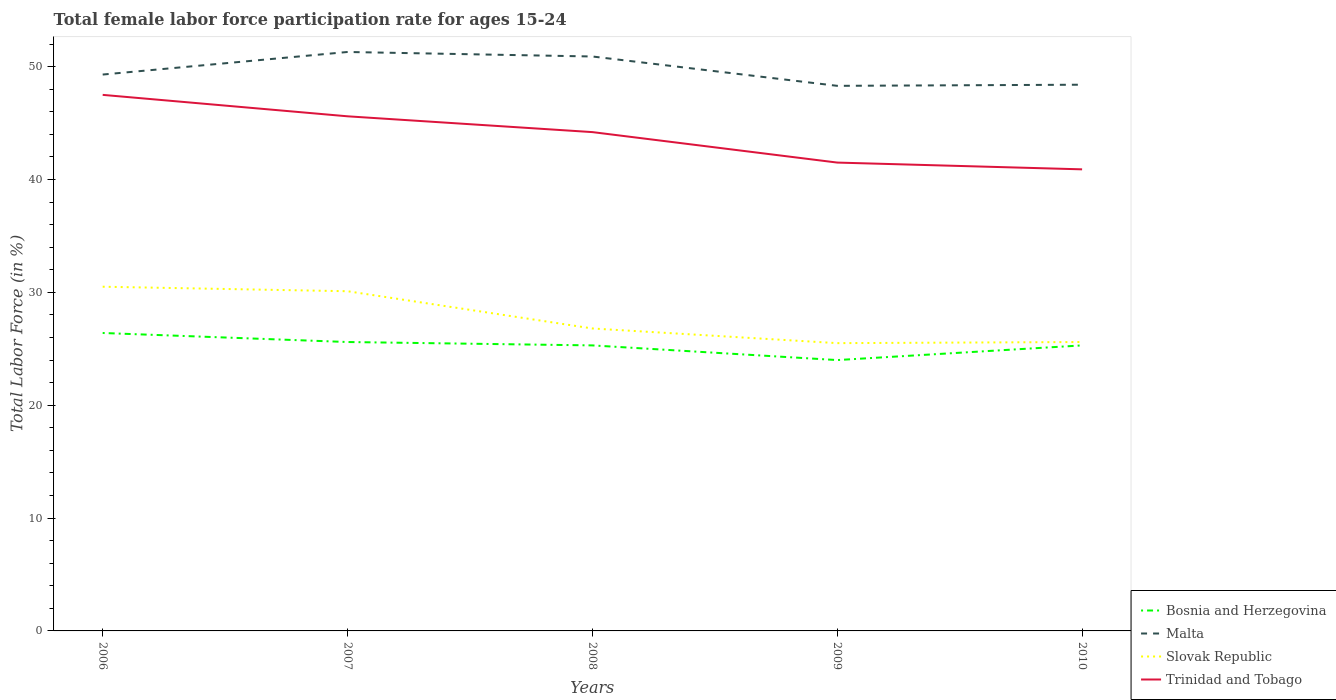Does the line corresponding to Trinidad and Tobago intersect with the line corresponding to Bosnia and Herzegovina?
Keep it short and to the point. No. Is the number of lines equal to the number of legend labels?
Give a very brief answer. Yes. Across all years, what is the maximum female labor force participation rate in Malta?
Provide a succinct answer. 48.3. What is the difference between the highest and the second highest female labor force participation rate in Malta?
Provide a short and direct response. 3. What is the difference between the highest and the lowest female labor force participation rate in Malta?
Give a very brief answer. 2. What is the difference between two consecutive major ticks on the Y-axis?
Offer a terse response. 10. How many legend labels are there?
Your answer should be compact. 4. How are the legend labels stacked?
Provide a succinct answer. Vertical. What is the title of the graph?
Provide a succinct answer. Total female labor force participation rate for ages 15-24. Does "Least developed countries" appear as one of the legend labels in the graph?
Provide a succinct answer. No. What is the label or title of the X-axis?
Keep it short and to the point. Years. What is the label or title of the Y-axis?
Your response must be concise. Total Labor Force (in %). What is the Total Labor Force (in %) of Bosnia and Herzegovina in 2006?
Keep it short and to the point. 26.4. What is the Total Labor Force (in %) in Malta in 2006?
Provide a short and direct response. 49.3. What is the Total Labor Force (in %) of Slovak Republic in 2006?
Make the answer very short. 30.5. What is the Total Labor Force (in %) in Trinidad and Tobago in 2006?
Ensure brevity in your answer.  47.5. What is the Total Labor Force (in %) in Bosnia and Herzegovina in 2007?
Your answer should be compact. 25.6. What is the Total Labor Force (in %) in Malta in 2007?
Keep it short and to the point. 51.3. What is the Total Labor Force (in %) in Slovak Republic in 2007?
Your answer should be compact. 30.1. What is the Total Labor Force (in %) of Trinidad and Tobago in 2007?
Offer a very short reply. 45.6. What is the Total Labor Force (in %) of Bosnia and Herzegovina in 2008?
Ensure brevity in your answer.  25.3. What is the Total Labor Force (in %) of Malta in 2008?
Make the answer very short. 50.9. What is the Total Labor Force (in %) of Slovak Republic in 2008?
Provide a succinct answer. 26.8. What is the Total Labor Force (in %) of Trinidad and Tobago in 2008?
Your answer should be compact. 44.2. What is the Total Labor Force (in %) of Bosnia and Herzegovina in 2009?
Give a very brief answer. 24. What is the Total Labor Force (in %) of Malta in 2009?
Offer a terse response. 48.3. What is the Total Labor Force (in %) in Trinidad and Tobago in 2009?
Provide a succinct answer. 41.5. What is the Total Labor Force (in %) of Bosnia and Herzegovina in 2010?
Provide a short and direct response. 25.3. What is the Total Labor Force (in %) of Malta in 2010?
Your answer should be compact. 48.4. What is the Total Labor Force (in %) in Slovak Republic in 2010?
Keep it short and to the point. 25.6. What is the Total Labor Force (in %) of Trinidad and Tobago in 2010?
Provide a succinct answer. 40.9. Across all years, what is the maximum Total Labor Force (in %) of Bosnia and Herzegovina?
Give a very brief answer. 26.4. Across all years, what is the maximum Total Labor Force (in %) in Malta?
Give a very brief answer. 51.3. Across all years, what is the maximum Total Labor Force (in %) in Slovak Republic?
Offer a very short reply. 30.5. Across all years, what is the maximum Total Labor Force (in %) of Trinidad and Tobago?
Give a very brief answer. 47.5. Across all years, what is the minimum Total Labor Force (in %) in Malta?
Your answer should be compact. 48.3. Across all years, what is the minimum Total Labor Force (in %) in Trinidad and Tobago?
Keep it short and to the point. 40.9. What is the total Total Labor Force (in %) in Bosnia and Herzegovina in the graph?
Offer a very short reply. 126.6. What is the total Total Labor Force (in %) of Malta in the graph?
Provide a succinct answer. 248.2. What is the total Total Labor Force (in %) in Slovak Republic in the graph?
Keep it short and to the point. 138.5. What is the total Total Labor Force (in %) of Trinidad and Tobago in the graph?
Offer a terse response. 219.7. What is the difference between the Total Labor Force (in %) in Malta in 2006 and that in 2007?
Your answer should be very brief. -2. What is the difference between the Total Labor Force (in %) of Trinidad and Tobago in 2006 and that in 2007?
Provide a succinct answer. 1.9. What is the difference between the Total Labor Force (in %) of Bosnia and Herzegovina in 2006 and that in 2008?
Your answer should be compact. 1.1. What is the difference between the Total Labor Force (in %) in Malta in 2006 and that in 2008?
Your response must be concise. -1.6. What is the difference between the Total Labor Force (in %) in Slovak Republic in 2006 and that in 2008?
Your response must be concise. 3.7. What is the difference between the Total Labor Force (in %) of Trinidad and Tobago in 2006 and that in 2008?
Your response must be concise. 3.3. What is the difference between the Total Labor Force (in %) in Bosnia and Herzegovina in 2006 and that in 2009?
Your response must be concise. 2.4. What is the difference between the Total Labor Force (in %) of Malta in 2006 and that in 2009?
Keep it short and to the point. 1. What is the difference between the Total Labor Force (in %) of Slovak Republic in 2006 and that in 2009?
Offer a terse response. 5. What is the difference between the Total Labor Force (in %) of Slovak Republic in 2006 and that in 2010?
Provide a short and direct response. 4.9. What is the difference between the Total Labor Force (in %) in Trinidad and Tobago in 2006 and that in 2010?
Ensure brevity in your answer.  6.6. What is the difference between the Total Labor Force (in %) of Malta in 2007 and that in 2008?
Make the answer very short. 0.4. What is the difference between the Total Labor Force (in %) in Slovak Republic in 2007 and that in 2008?
Provide a succinct answer. 3.3. What is the difference between the Total Labor Force (in %) of Bosnia and Herzegovina in 2007 and that in 2009?
Give a very brief answer. 1.6. What is the difference between the Total Labor Force (in %) of Malta in 2007 and that in 2009?
Provide a short and direct response. 3. What is the difference between the Total Labor Force (in %) of Trinidad and Tobago in 2007 and that in 2009?
Your answer should be very brief. 4.1. What is the difference between the Total Labor Force (in %) in Bosnia and Herzegovina in 2007 and that in 2010?
Your answer should be compact. 0.3. What is the difference between the Total Labor Force (in %) of Trinidad and Tobago in 2007 and that in 2010?
Make the answer very short. 4.7. What is the difference between the Total Labor Force (in %) in Bosnia and Herzegovina in 2008 and that in 2009?
Your response must be concise. 1.3. What is the difference between the Total Labor Force (in %) in Malta in 2008 and that in 2009?
Your response must be concise. 2.6. What is the difference between the Total Labor Force (in %) in Slovak Republic in 2008 and that in 2009?
Make the answer very short. 1.3. What is the difference between the Total Labor Force (in %) of Trinidad and Tobago in 2008 and that in 2009?
Your answer should be compact. 2.7. What is the difference between the Total Labor Force (in %) in Bosnia and Herzegovina in 2008 and that in 2010?
Your response must be concise. 0. What is the difference between the Total Labor Force (in %) in Slovak Republic in 2008 and that in 2010?
Keep it short and to the point. 1.2. What is the difference between the Total Labor Force (in %) in Trinidad and Tobago in 2008 and that in 2010?
Your response must be concise. 3.3. What is the difference between the Total Labor Force (in %) of Malta in 2009 and that in 2010?
Your answer should be very brief. -0.1. What is the difference between the Total Labor Force (in %) in Bosnia and Herzegovina in 2006 and the Total Labor Force (in %) in Malta in 2007?
Give a very brief answer. -24.9. What is the difference between the Total Labor Force (in %) in Bosnia and Herzegovina in 2006 and the Total Labor Force (in %) in Slovak Republic in 2007?
Your answer should be very brief. -3.7. What is the difference between the Total Labor Force (in %) of Bosnia and Herzegovina in 2006 and the Total Labor Force (in %) of Trinidad and Tobago in 2007?
Your answer should be compact. -19.2. What is the difference between the Total Labor Force (in %) of Malta in 2006 and the Total Labor Force (in %) of Slovak Republic in 2007?
Offer a terse response. 19.2. What is the difference between the Total Labor Force (in %) of Slovak Republic in 2006 and the Total Labor Force (in %) of Trinidad and Tobago in 2007?
Offer a very short reply. -15.1. What is the difference between the Total Labor Force (in %) of Bosnia and Herzegovina in 2006 and the Total Labor Force (in %) of Malta in 2008?
Provide a short and direct response. -24.5. What is the difference between the Total Labor Force (in %) in Bosnia and Herzegovina in 2006 and the Total Labor Force (in %) in Trinidad and Tobago in 2008?
Your answer should be very brief. -17.8. What is the difference between the Total Labor Force (in %) in Malta in 2006 and the Total Labor Force (in %) in Trinidad and Tobago in 2008?
Offer a terse response. 5.1. What is the difference between the Total Labor Force (in %) in Slovak Republic in 2006 and the Total Labor Force (in %) in Trinidad and Tobago in 2008?
Your answer should be very brief. -13.7. What is the difference between the Total Labor Force (in %) of Bosnia and Herzegovina in 2006 and the Total Labor Force (in %) of Malta in 2009?
Your response must be concise. -21.9. What is the difference between the Total Labor Force (in %) in Bosnia and Herzegovina in 2006 and the Total Labor Force (in %) in Trinidad and Tobago in 2009?
Your response must be concise. -15.1. What is the difference between the Total Labor Force (in %) of Malta in 2006 and the Total Labor Force (in %) of Slovak Republic in 2009?
Give a very brief answer. 23.8. What is the difference between the Total Labor Force (in %) in Malta in 2006 and the Total Labor Force (in %) in Trinidad and Tobago in 2009?
Ensure brevity in your answer.  7.8. What is the difference between the Total Labor Force (in %) of Bosnia and Herzegovina in 2006 and the Total Labor Force (in %) of Trinidad and Tobago in 2010?
Provide a short and direct response. -14.5. What is the difference between the Total Labor Force (in %) of Malta in 2006 and the Total Labor Force (in %) of Slovak Republic in 2010?
Offer a very short reply. 23.7. What is the difference between the Total Labor Force (in %) of Malta in 2006 and the Total Labor Force (in %) of Trinidad and Tobago in 2010?
Offer a terse response. 8.4. What is the difference between the Total Labor Force (in %) in Slovak Republic in 2006 and the Total Labor Force (in %) in Trinidad and Tobago in 2010?
Keep it short and to the point. -10.4. What is the difference between the Total Labor Force (in %) of Bosnia and Herzegovina in 2007 and the Total Labor Force (in %) of Malta in 2008?
Provide a succinct answer. -25.3. What is the difference between the Total Labor Force (in %) of Bosnia and Herzegovina in 2007 and the Total Labor Force (in %) of Slovak Republic in 2008?
Ensure brevity in your answer.  -1.2. What is the difference between the Total Labor Force (in %) in Bosnia and Herzegovina in 2007 and the Total Labor Force (in %) in Trinidad and Tobago in 2008?
Keep it short and to the point. -18.6. What is the difference between the Total Labor Force (in %) in Malta in 2007 and the Total Labor Force (in %) in Slovak Republic in 2008?
Provide a succinct answer. 24.5. What is the difference between the Total Labor Force (in %) of Malta in 2007 and the Total Labor Force (in %) of Trinidad and Tobago in 2008?
Ensure brevity in your answer.  7.1. What is the difference between the Total Labor Force (in %) in Slovak Republic in 2007 and the Total Labor Force (in %) in Trinidad and Tobago in 2008?
Your response must be concise. -14.1. What is the difference between the Total Labor Force (in %) in Bosnia and Herzegovina in 2007 and the Total Labor Force (in %) in Malta in 2009?
Make the answer very short. -22.7. What is the difference between the Total Labor Force (in %) in Bosnia and Herzegovina in 2007 and the Total Labor Force (in %) in Trinidad and Tobago in 2009?
Make the answer very short. -15.9. What is the difference between the Total Labor Force (in %) in Malta in 2007 and the Total Labor Force (in %) in Slovak Republic in 2009?
Provide a succinct answer. 25.8. What is the difference between the Total Labor Force (in %) in Malta in 2007 and the Total Labor Force (in %) in Trinidad and Tobago in 2009?
Provide a short and direct response. 9.8. What is the difference between the Total Labor Force (in %) in Slovak Republic in 2007 and the Total Labor Force (in %) in Trinidad and Tobago in 2009?
Offer a terse response. -11.4. What is the difference between the Total Labor Force (in %) of Bosnia and Herzegovina in 2007 and the Total Labor Force (in %) of Malta in 2010?
Offer a terse response. -22.8. What is the difference between the Total Labor Force (in %) of Bosnia and Herzegovina in 2007 and the Total Labor Force (in %) of Trinidad and Tobago in 2010?
Offer a terse response. -15.3. What is the difference between the Total Labor Force (in %) in Malta in 2007 and the Total Labor Force (in %) in Slovak Republic in 2010?
Give a very brief answer. 25.7. What is the difference between the Total Labor Force (in %) in Slovak Republic in 2007 and the Total Labor Force (in %) in Trinidad and Tobago in 2010?
Ensure brevity in your answer.  -10.8. What is the difference between the Total Labor Force (in %) in Bosnia and Herzegovina in 2008 and the Total Labor Force (in %) in Malta in 2009?
Your answer should be very brief. -23. What is the difference between the Total Labor Force (in %) in Bosnia and Herzegovina in 2008 and the Total Labor Force (in %) in Trinidad and Tobago in 2009?
Keep it short and to the point. -16.2. What is the difference between the Total Labor Force (in %) in Malta in 2008 and the Total Labor Force (in %) in Slovak Republic in 2009?
Give a very brief answer. 25.4. What is the difference between the Total Labor Force (in %) in Malta in 2008 and the Total Labor Force (in %) in Trinidad and Tobago in 2009?
Your answer should be very brief. 9.4. What is the difference between the Total Labor Force (in %) in Slovak Republic in 2008 and the Total Labor Force (in %) in Trinidad and Tobago in 2009?
Make the answer very short. -14.7. What is the difference between the Total Labor Force (in %) in Bosnia and Herzegovina in 2008 and the Total Labor Force (in %) in Malta in 2010?
Offer a terse response. -23.1. What is the difference between the Total Labor Force (in %) of Bosnia and Herzegovina in 2008 and the Total Labor Force (in %) of Slovak Republic in 2010?
Offer a very short reply. -0.3. What is the difference between the Total Labor Force (in %) of Bosnia and Herzegovina in 2008 and the Total Labor Force (in %) of Trinidad and Tobago in 2010?
Provide a succinct answer. -15.6. What is the difference between the Total Labor Force (in %) in Malta in 2008 and the Total Labor Force (in %) in Slovak Republic in 2010?
Offer a very short reply. 25.3. What is the difference between the Total Labor Force (in %) in Slovak Republic in 2008 and the Total Labor Force (in %) in Trinidad and Tobago in 2010?
Provide a succinct answer. -14.1. What is the difference between the Total Labor Force (in %) in Bosnia and Herzegovina in 2009 and the Total Labor Force (in %) in Malta in 2010?
Your answer should be compact. -24.4. What is the difference between the Total Labor Force (in %) of Bosnia and Herzegovina in 2009 and the Total Labor Force (in %) of Trinidad and Tobago in 2010?
Offer a terse response. -16.9. What is the difference between the Total Labor Force (in %) in Malta in 2009 and the Total Labor Force (in %) in Slovak Republic in 2010?
Make the answer very short. 22.7. What is the difference between the Total Labor Force (in %) of Slovak Republic in 2009 and the Total Labor Force (in %) of Trinidad and Tobago in 2010?
Provide a succinct answer. -15.4. What is the average Total Labor Force (in %) of Bosnia and Herzegovina per year?
Your answer should be compact. 25.32. What is the average Total Labor Force (in %) of Malta per year?
Make the answer very short. 49.64. What is the average Total Labor Force (in %) of Slovak Republic per year?
Make the answer very short. 27.7. What is the average Total Labor Force (in %) of Trinidad and Tobago per year?
Your answer should be very brief. 43.94. In the year 2006, what is the difference between the Total Labor Force (in %) in Bosnia and Herzegovina and Total Labor Force (in %) in Malta?
Your answer should be compact. -22.9. In the year 2006, what is the difference between the Total Labor Force (in %) in Bosnia and Herzegovina and Total Labor Force (in %) in Slovak Republic?
Ensure brevity in your answer.  -4.1. In the year 2006, what is the difference between the Total Labor Force (in %) of Bosnia and Herzegovina and Total Labor Force (in %) of Trinidad and Tobago?
Provide a short and direct response. -21.1. In the year 2006, what is the difference between the Total Labor Force (in %) of Slovak Republic and Total Labor Force (in %) of Trinidad and Tobago?
Keep it short and to the point. -17. In the year 2007, what is the difference between the Total Labor Force (in %) in Bosnia and Herzegovina and Total Labor Force (in %) in Malta?
Give a very brief answer. -25.7. In the year 2007, what is the difference between the Total Labor Force (in %) of Malta and Total Labor Force (in %) of Slovak Republic?
Give a very brief answer. 21.2. In the year 2007, what is the difference between the Total Labor Force (in %) of Slovak Republic and Total Labor Force (in %) of Trinidad and Tobago?
Make the answer very short. -15.5. In the year 2008, what is the difference between the Total Labor Force (in %) in Bosnia and Herzegovina and Total Labor Force (in %) in Malta?
Offer a terse response. -25.6. In the year 2008, what is the difference between the Total Labor Force (in %) of Bosnia and Herzegovina and Total Labor Force (in %) of Trinidad and Tobago?
Offer a terse response. -18.9. In the year 2008, what is the difference between the Total Labor Force (in %) in Malta and Total Labor Force (in %) in Slovak Republic?
Provide a short and direct response. 24.1. In the year 2008, what is the difference between the Total Labor Force (in %) of Slovak Republic and Total Labor Force (in %) of Trinidad and Tobago?
Your response must be concise. -17.4. In the year 2009, what is the difference between the Total Labor Force (in %) in Bosnia and Herzegovina and Total Labor Force (in %) in Malta?
Make the answer very short. -24.3. In the year 2009, what is the difference between the Total Labor Force (in %) in Bosnia and Herzegovina and Total Labor Force (in %) in Trinidad and Tobago?
Ensure brevity in your answer.  -17.5. In the year 2009, what is the difference between the Total Labor Force (in %) in Malta and Total Labor Force (in %) in Slovak Republic?
Your answer should be compact. 22.8. In the year 2009, what is the difference between the Total Labor Force (in %) of Malta and Total Labor Force (in %) of Trinidad and Tobago?
Keep it short and to the point. 6.8. In the year 2009, what is the difference between the Total Labor Force (in %) of Slovak Republic and Total Labor Force (in %) of Trinidad and Tobago?
Ensure brevity in your answer.  -16. In the year 2010, what is the difference between the Total Labor Force (in %) of Bosnia and Herzegovina and Total Labor Force (in %) of Malta?
Your response must be concise. -23.1. In the year 2010, what is the difference between the Total Labor Force (in %) in Bosnia and Herzegovina and Total Labor Force (in %) in Trinidad and Tobago?
Provide a short and direct response. -15.6. In the year 2010, what is the difference between the Total Labor Force (in %) of Malta and Total Labor Force (in %) of Slovak Republic?
Keep it short and to the point. 22.8. In the year 2010, what is the difference between the Total Labor Force (in %) of Malta and Total Labor Force (in %) of Trinidad and Tobago?
Give a very brief answer. 7.5. In the year 2010, what is the difference between the Total Labor Force (in %) of Slovak Republic and Total Labor Force (in %) of Trinidad and Tobago?
Your response must be concise. -15.3. What is the ratio of the Total Labor Force (in %) of Bosnia and Herzegovina in 2006 to that in 2007?
Provide a succinct answer. 1.03. What is the ratio of the Total Labor Force (in %) in Slovak Republic in 2006 to that in 2007?
Provide a short and direct response. 1.01. What is the ratio of the Total Labor Force (in %) in Trinidad and Tobago in 2006 to that in 2007?
Your answer should be very brief. 1.04. What is the ratio of the Total Labor Force (in %) in Bosnia and Herzegovina in 2006 to that in 2008?
Offer a very short reply. 1.04. What is the ratio of the Total Labor Force (in %) of Malta in 2006 to that in 2008?
Provide a short and direct response. 0.97. What is the ratio of the Total Labor Force (in %) in Slovak Republic in 2006 to that in 2008?
Keep it short and to the point. 1.14. What is the ratio of the Total Labor Force (in %) in Trinidad and Tobago in 2006 to that in 2008?
Make the answer very short. 1.07. What is the ratio of the Total Labor Force (in %) in Malta in 2006 to that in 2009?
Offer a very short reply. 1.02. What is the ratio of the Total Labor Force (in %) in Slovak Republic in 2006 to that in 2009?
Give a very brief answer. 1.2. What is the ratio of the Total Labor Force (in %) of Trinidad and Tobago in 2006 to that in 2009?
Make the answer very short. 1.14. What is the ratio of the Total Labor Force (in %) in Bosnia and Herzegovina in 2006 to that in 2010?
Keep it short and to the point. 1.04. What is the ratio of the Total Labor Force (in %) of Malta in 2006 to that in 2010?
Provide a short and direct response. 1.02. What is the ratio of the Total Labor Force (in %) in Slovak Republic in 2006 to that in 2010?
Offer a very short reply. 1.19. What is the ratio of the Total Labor Force (in %) of Trinidad and Tobago in 2006 to that in 2010?
Your answer should be compact. 1.16. What is the ratio of the Total Labor Force (in %) of Bosnia and Herzegovina in 2007 to that in 2008?
Provide a short and direct response. 1.01. What is the ratio of the Total Labor Force (in %) in Malta in 2007 to that in 2008?
Give a very brief answer. 1.01. What is the ratio of the Total Labor Force (in %) of Slovak Republic in 2007 to that in 2008?
Provide a succinct answer. 1.12. What is the ratio of the Total Labor Force (in %) of Trinidad and Tobago in 2007 to that in 2008?
Ensure brevity in your answer.  1.03. What is the ratio of the Total Labor Force (in %) of Bosnia and Herzegovina in 2007 to that in 2009?
Your response must be concise. 1.07. What is the ratio of the Total Labor Force (in %) of Malta in 2007 to that in 2009?
Keep it short and to the point. 1.06. What is the ratio of the Total Labor Force (in %) of Slovak Republic in 2007 to that in 2009?
Your response must be concise. 1.18. What is the ratio of the Total Labor Force (in %) of Trinidad and Tobago in 2007 to that in 2009?
Provide a short and direct response. 1.1. What is the ratio of the Total Labor Force (in %) in Bosnia and Herzegovina in 2007 to that in 2010?
Make the answer very short. 1.01. What is the ratio of the Total Labor Force (in %) of Malta in 2007 to that in 2010?
Keep it short and to the point. 1.06. What is the ratio of the Total Labor Force (in %) of Slovak Republic in 2007 to that in 2010?
Provide a short and direct response. 1.18. What is the ratio of the Total Labor Force (in %) of Trinidad and Tobago in 2007 to that in 2010?
Provide a short and direct response. 1.11. What is the ratio of the Total Labor Force (in %) of Bosnia and Herzegovina in 2008 to that in 2009?
Your answer should be compact. 1.05. What is the ratio of the Total Labor Force (in %) in Malta in 2008 to that in 2009?
Give a very brief answer. 1.05. What is the ratio of the Total Labor Force (in %) in Slovak Republic in 2008 to that in 2009?
Ensure brevity in your answer.  1.05. What is the ratio of the Total Labor Force (in %) of Trinidad and Tobago in 2008 to that in 2009?
Give a very brief answer. 1.07. What is the ratio of the Total Labor Force (in %) in Malta in 2008 to that in 2010?
Offer a very short reply. 1.05. What is the ratio of the Total Labor Force (in %) in Slovak Republic in 2008 to that in 2010?
Ensure brevity in your answer.  1.05. What is the ratio of the Total Labor Force (in %) of Trinidad and Tobago in 2008 to that in 2010?
Your response must be concise. 1.08. What is the ratio of the Total Labor Force (in %) of Bosnia and Herzegovina in 2009 to that in 2010?
Your response must be concise. 0.95. What is the ratio of the Total Labor Force (in %) in Trinidad and Tobago in 2009 to that in 2010?
Make the answer very short. 1.01. What is the difference between the highest and the second highest Total Labor Force (in %) in Bosnia and Herzegovina?
Ensure brevity in your answer.  0.8. What is the difference between the highest and the second highest Total Labor Force (in %) in Malta?
Your answer should be very brief. 0.4. What is the difference between the highest and the lowest Total Labor Force (in %) of Malta?
Make the answer very short. 3. What is the difference between the highest and the lowest Total Labor Force (in %) in Slovak Republic?
Offer a very short reply. 5. 